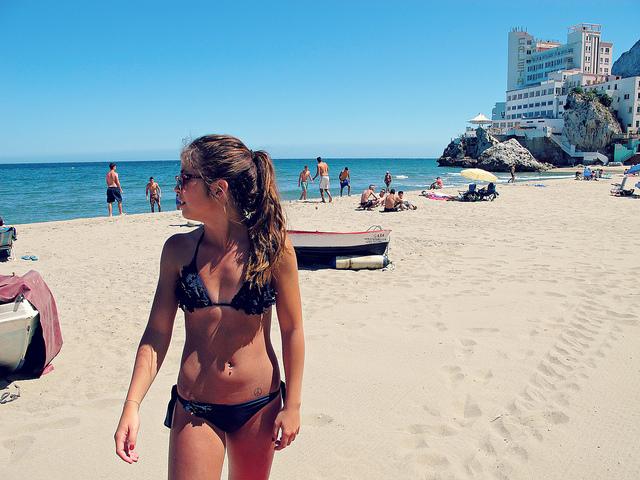Is this photo outdoors?
Concise answer only. Yes. Is this woman sitting in the shade?
Concise answer only. No. How many people are on the beach?
Keep it brief. 14. What is the woman posing in front of?
Give a very brief answer. Beach. Is she wearing a bikini?
Answer briefly. Yes. 